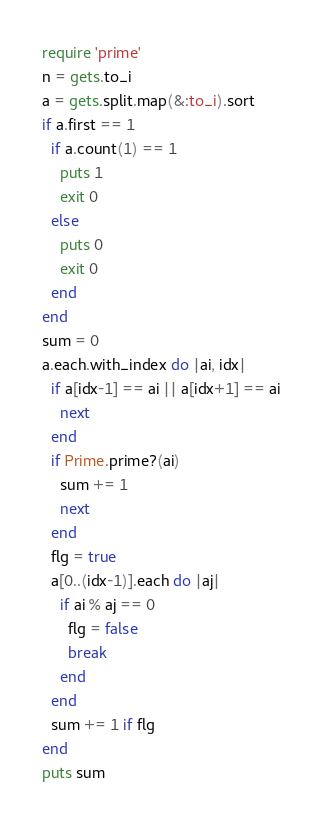<code> <loc_0><loc_0><loc_500><loc_500><_Ruby_>require 'prime'
n = gets.to_i
a = gets.split.map(&:to_i).sort
if a.first == 1
  if a.count(1) == 1
    puts 1
    exit 0
  else
    puts 0
    exit 0
  end
end
sum = 0
a.each.with_index do |ai, idx|
  if a[idx-1] == ai || a[idx+1] == ai
    next
  end
  if Prime.prime?(ai)
    sum += 1
    next
  end
  flg = true
  a[0..(idx-1)].each do |aj|
    if ai % aj == 0
      flg = false
      break
    end
  end
  sum += 1 if flg
end
puts sum</code> 